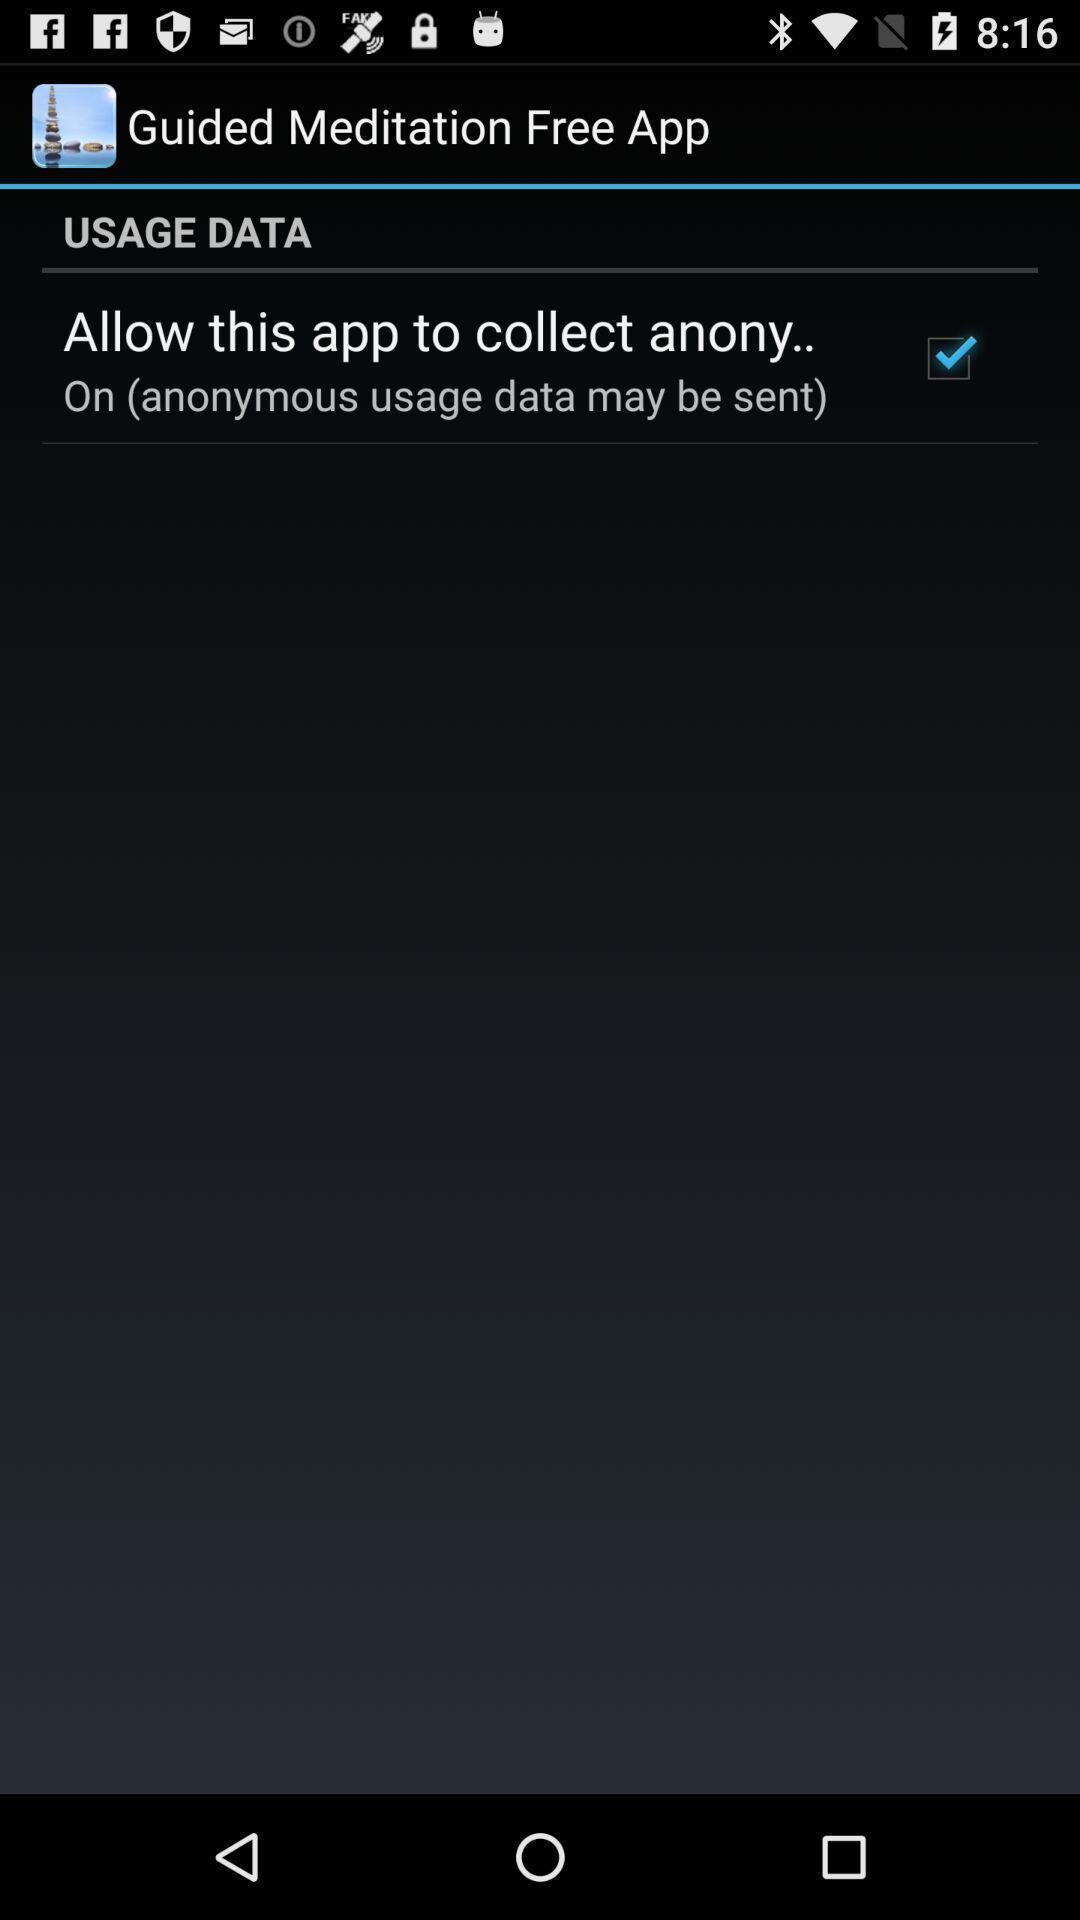Tell me about the visual elements in this screen capture. Usage data allowing in this application. 